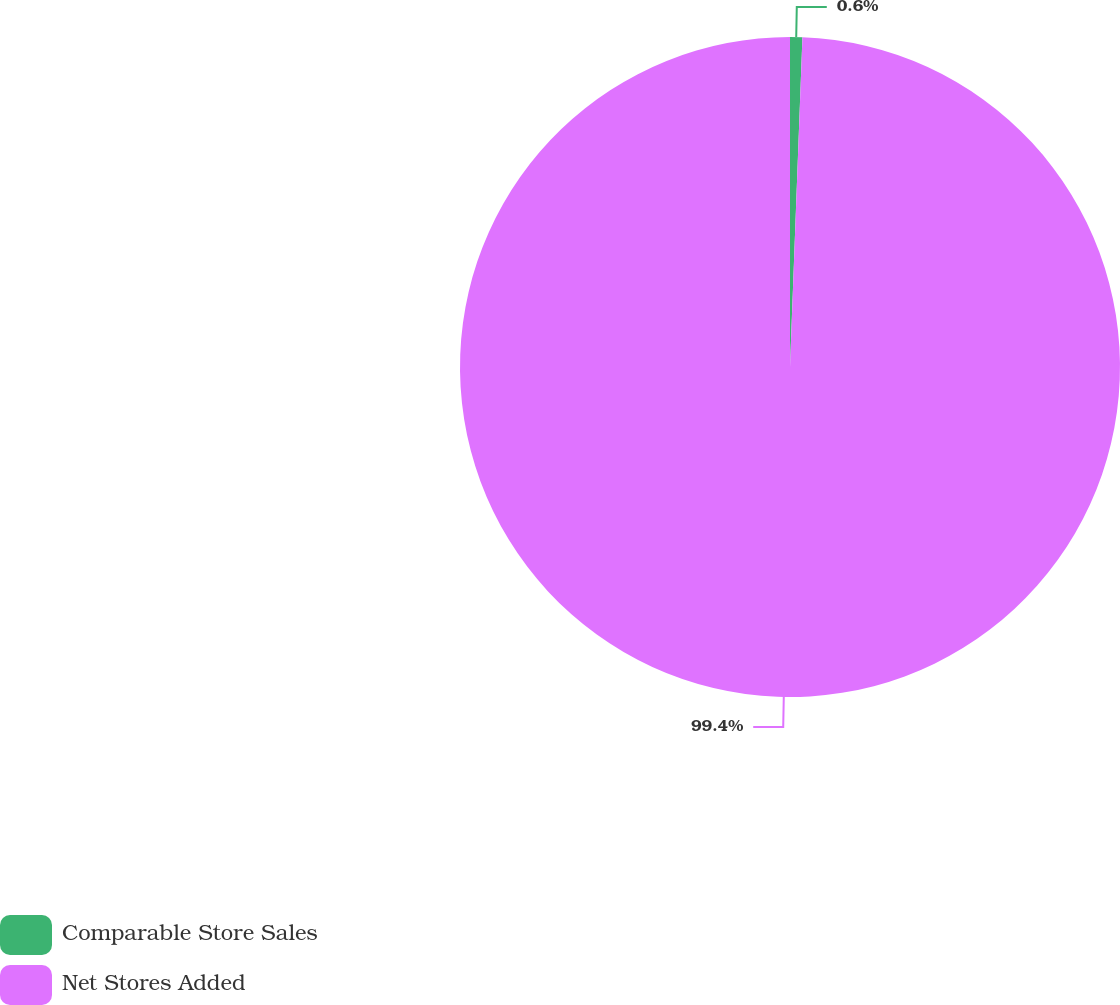Convert chart to OTSL. <chart><loc_0><loc_0><loc_500><loc_500><pie_chart><fcel>Comparable Store Sales<fcel>Net Stores Added<nl><fcel>0.6%<fcel>99.4%<nl></chart> 